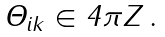<formula> <loc_0><loc_0><loc_500><loc_500>\Theta _ { i k } \in 4 \pi { \boldmath Z } \, .</formula> 